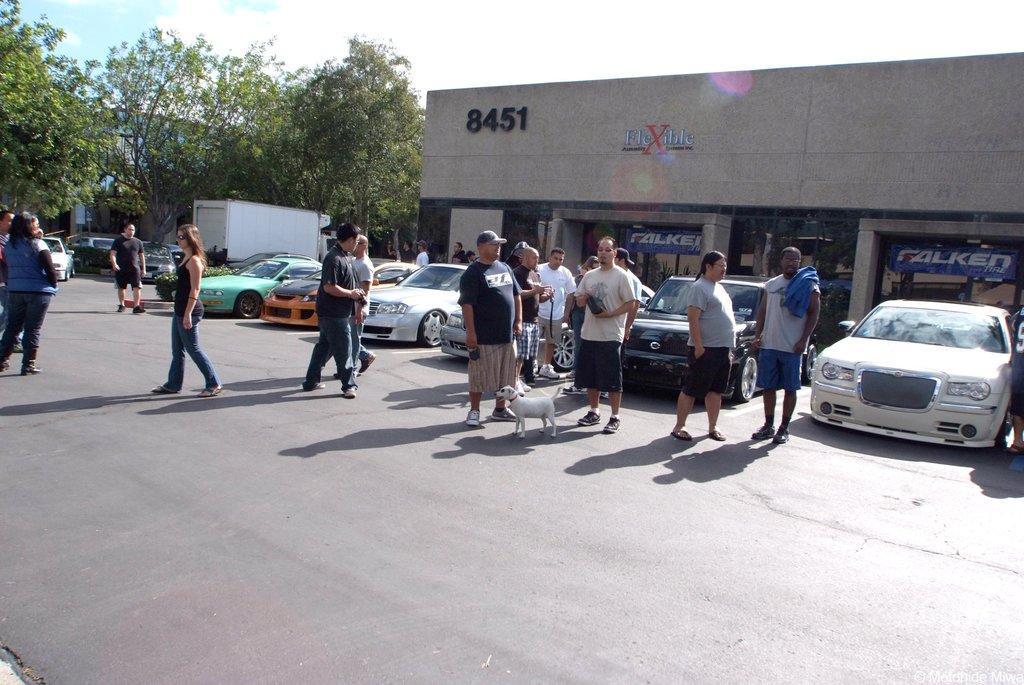In one or two sentences, can you explain what this image depicts? In this image we can see group of persons in front of the mall. And in the front region some text is written on it. And we can see the dog. And we can see some cars has been parked. And surrounding trees are seen. And clouds in the sky. 